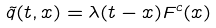<formula> <loc_0><loc_0><loc_500><loc_500>\tilde { q } ( t , x ) = \lambda ( t - x ) F ^ { c } ( x )</formula> 